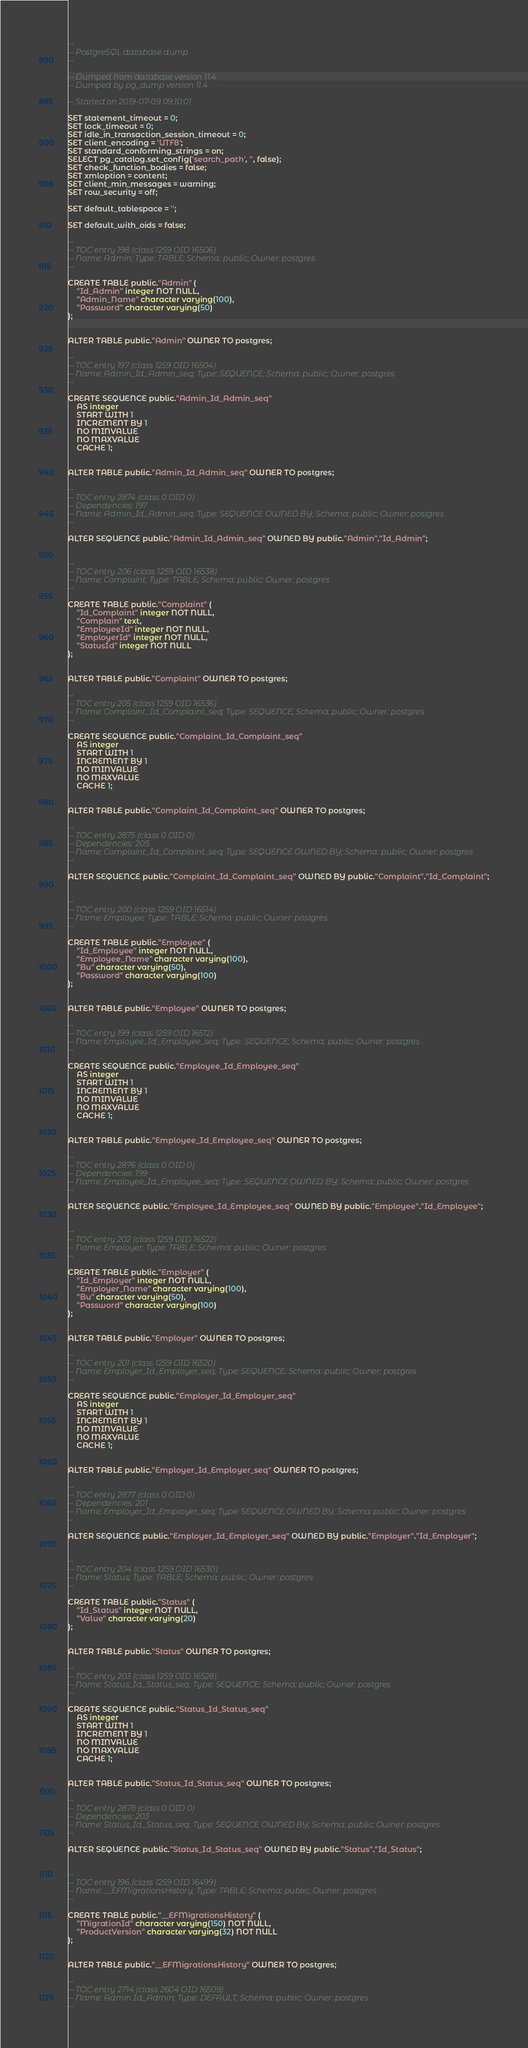<code> <loc_0><loc_0><loc_500><loc_500><_SQL_>--
-- PostgreSQL database dump
--

-- Dumped from database version 11.4
-- Dumped by pg_dump version 11.4

-- Started on 2019-07-09 09:10:01

SET statement_timeout = 0;
SET lock_timeout = 0;
SET idle_in_transaction_session_timeout = 0;
SET client_encoding = 'UTF8';
SET standard_conforming_strings = on;
SELECT pg_catalog.set_config('search_path', '', false);
SET check_function_bodies = false;
SET xmloption = content;
SET client_min_messages = warning;
SET row_security = off;

SET default_tablespace = '';

SET default_with_oids = false;

--
-- TOC entry 198 (class 1259 OID 16506)
-- Name: Admin; Type: TABLE; Schema: public; Owner: postgres
--

CREATE TABLE public."Admin" (
    "Id_Admin" integer NOT NULL,
    "Admin_Name" character varying(100),
    "Password" character varying(50)
);


ALTER TABLE public."Admin" OWNER TO postgres;

--
-- TOC entry 197 (class 1259 OID 16504)
-- Name: Admin_Id_Admin_seq; Type: SEQUENCE; Schema: public; Owner: postgres
--

CREATE SEQUENCE public."Admin_Id_Admin_seq"
    AS integer
    START WITH 1
    INCREMENT BY 1
    NO MINVALUE
    NO MAXVALUE
    CACHE 1;


ALTER TABLE public."Admin_Id_Admin_seq" OWNER TO postgres;

--
-- TOC entry 2874 (class 0 OID 0)
-- Dependencies: 197
-- Name: Admin_Id_Admin_seq; Type: SEQUENCE OWNED BY; Schema: public; Owner: postgres
--

ALTER SEQUENCE public."Admin_Id_Admin_seq" OWNED BY public."Admin"."Id_Admin";


--
-- TOC entry 206 (class 1259 OID 16538)
-- Name: Complaint; Type: TABLE; Schema: public; Owner: postgres
--

CREATE TABLE public."Complaint" (
    "Id_Complaint" integer NOT NULL,
    "Complain" text,
    "EmployeeId" integer NOT NULL,
    "EmployerId" integer NOT NULL,
    "StatusId" integer NOT NULL
);


ALTER TABLE public."Complaint" OWNER TO postgres;

--
-- TOC entry 205 (class 1259 OID 16536)
-- Name: Complaint_Id_Complaint_seq; Type: SEQUENCE; Schema: public; Owner: postgres
--

CREATE SEQUENCE public."Complaint_Id_Complaint_seq"
    AS integer
    START WITH 1
    INCREMENT BY 1
    NO MINVALUE
    NO MAXVALUE
    CACHE 1;


ALTER TABLE public."Complaint_Id_Complaint_seq" OWNER TO postgres;

--
-- TOC entry 2875 (class 0 OID 0)
-- Dependencies: 205
-- Name: Complaint_Id_Complaint_seq; Type: SEQUENCE OWNED BY; Schema: public; Owner: postgres
--

ALTER SEQUENCE public."Complaint_Id_Complaint_seq" OWNED BY public."Complaint"."Id_Complaint";


--
-- TOC entry 200 (class 1259 OID 16514)
-- Name: Employee; Type: TABLE; Schema: public; Owner: postgres
--

CREATE TABLE public."Employee" (
    "Id_Employee" integer NOT NULL,
    "Employee_Name" character varying(100),
    "Bu" character varying(50),
    "Password" character varying(100)
);


ALTER TABLE public."Employee" OWNER TO postgres;

--
-- TOC entry 199 (class 1259 OID 16512)
-- Name: Employee_Id_Employee_seq; Type: SEQUENCE; Schema: public; Owner: postgres
--

CREATE SEQUENCE public."Employee_Id_Employee_seq"
    AS integer
    START WITH 1
    INCREMENT BY 1
    NO MINVALUE
    NO MAXVALUE
    CACHE 1;


ALTER TABLE public."Employee_Id_Employee_seq" OWNER TO postgres;

--
-- TOC entry 2876 (class 0 OID 0)
-- Dependencies: 199
-- Name: Employee_Id_Employee_seq; Type: SEQUENCE OWNED BY; Schema: public; Owner: postgres
--

ALTER SEQUENCE public."Employee_Id_Employee_seq" OWNED BY public."Employee"."Id_Employee";


--
-- TOC entry 202 (class 1259 OID 16522)
-- Name: Employer; Type: TABLE; Schema: public; Owner: postgres
--

CREATE TABLE public."Employer" (
    "Id_Employer" integer NOT NULL,
    "Employer_Name" character varying(100),
    "Bu" character varying(50),
    "Password" character varying(100)
);


ALTER TABLE public."Employer" OWNER TO postgres;

--
-- TOC entry 201 (class 1259 OID 16520)
-- Name: Employer_Id_Employer_seq; Type: SEQUENCE; Schema: public; Owner: postgres
--

CREATE SEQUENCE public."Employer_Id_Employer_seq"
    AS integer
    START WITH 1
    INCREMENT BY 1
    NO MINVALUE
    NO MAXVALUE
    CACHE 1;


ALTER TABLE public."Employer_Id_Employer_seq" OWNER TO postgres;

--
-- TOC entry 2877 (class 0 OID 0)
-- Dependencies: 201
-- Name: Employer_Id_Employer_seq; Type: SEQUENCE OWNED BY; Schema: public; Owner: postgres
--

ALTER SEQUENCE public."Employer_Id_Employer_seq" OWNED BY public."Employer"."Id_Employer";


--
-- TOC entry 204 (class 1259 OID 16530)
-- Name: Status; Type: TABLE; Schema: public; Owner: postgres
--

CREATE TABLE public."Status" (
    "Id_Status" integer NOT NULL,
    "Value" character varying(20)
);


ALTER TABLE public."Status" OWNER TO postgres;

--
-- TOC entry 203 (class 1259 OID 16528)
-- Name: Status_Id_Status_seq; Type: SEQUENCE; Schema: public; Owner: postgres
--

CREATE SEQUENCE public."Status_Id_Status_seq"
    AS integer
    START WITH 1
    INCREMENT BY 1
    NO MINVALUE
    NO MAXVALUE
    CACHE 1;


ALTER TABLE public."Status_Id_Status_seq" OWNER TO postgres;

--
-- TOC entry 2878 (class 0 OID 0)
-- Dependencies: 203
-- Name: Status_Id_Status_seq; Type: SEQUENCE OWNED BY; Schema: public; Owner: postgres
--

ALTER SEQUENCE public."Status_Id_Status_seq" OWNED BY public."Status"."Id_Status";


--
-- TOC entry 196 (class 1259 OID 16499)
-- Name: __EFMigrationsHistory; Type: TABLE; Schema: public; Owner: postgres
--

CREATE TABLE public."__EFMigrationsHistory" (
    "MigrationId" character varying(150) NOT NULL,
    "ProductVersion" character varying(32) NOT NULL
);


ALTER TABLE public."__EFMigrationsHistory" OWNER TO postgres;

--
-- TOC entry 2714 (class 2604 OID 16509)
-- Name: Admin Id_Admin; Type: DEFAULT; Schema: public; Owner: postgres
--
</code> 